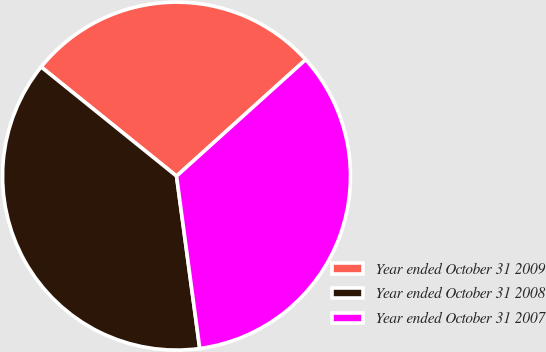<chart> <loc_0><loc_0><loc_500><loc_500><pie_chart><fcel>Year ended October 31 2009<fcel>Year ended October 31 2008<fcel>Year ended October 31 2007<nl><fcel>27.52%<fcel>37.93%<fcel>34.55%<nl></chart> 